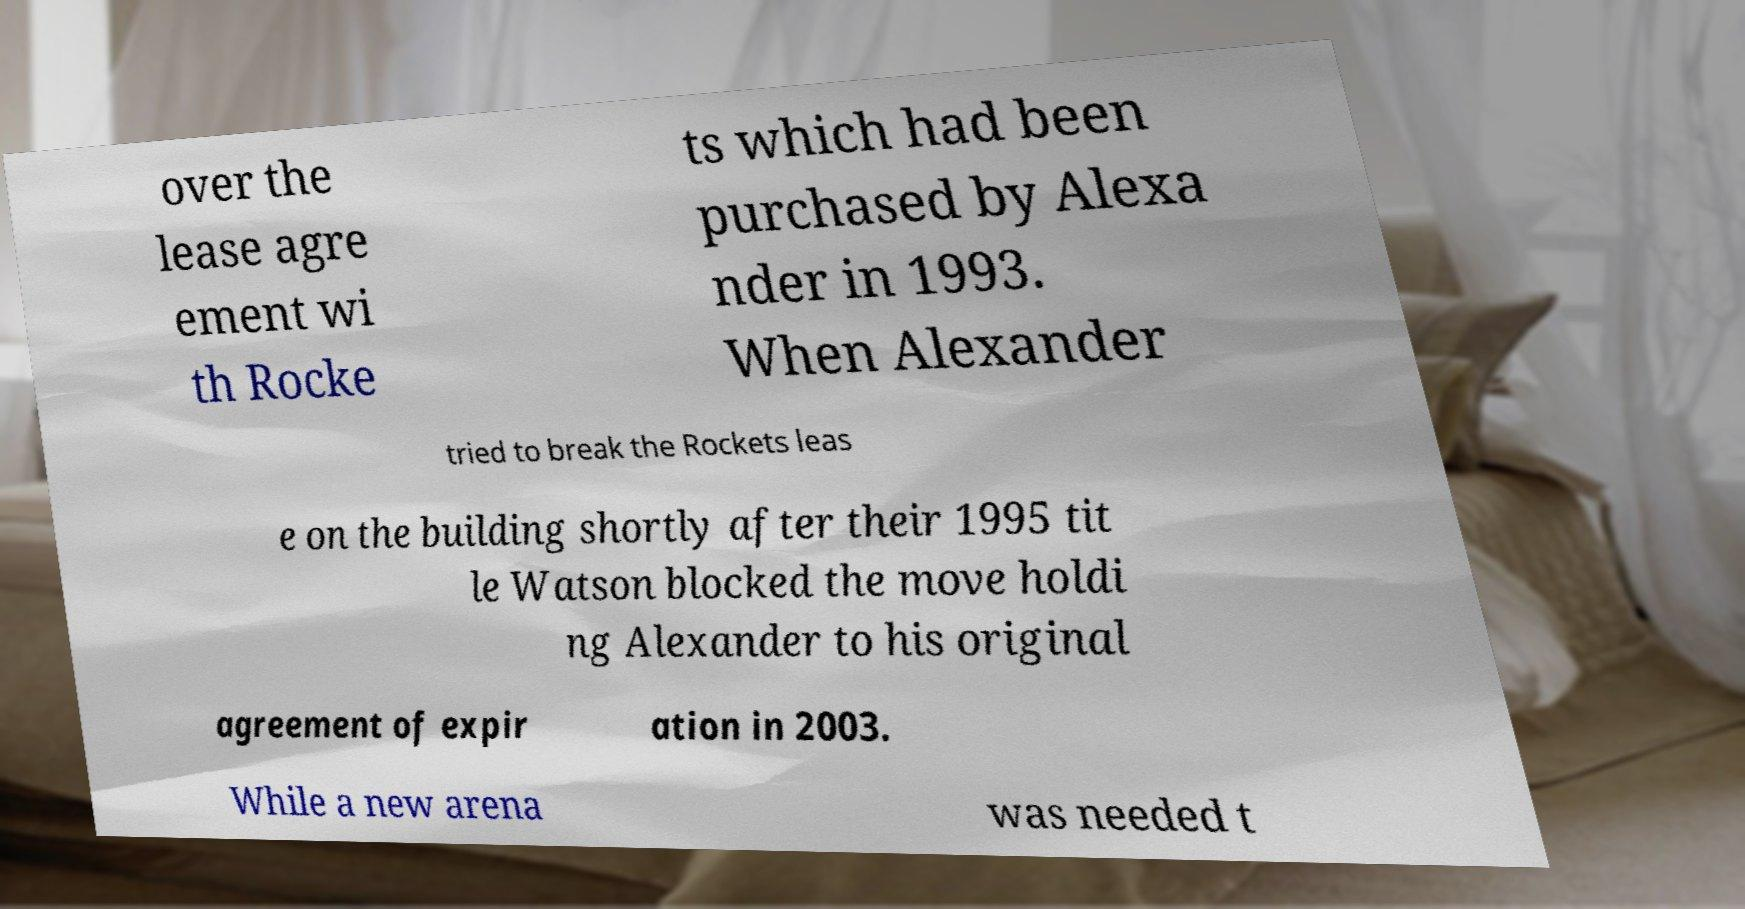I need the written content from this picture converted into text. Can you do that? over the lease agre ement wi th Rocke ts which had been purchased by Alexa nder in 1993. When Alexander tried to break the Rockets leas e on the building shortly after their 1995 tit le Watson blocked the move holdi ng Alexander to his original agreement of expir ation in 2003. While a new arena was needed t 